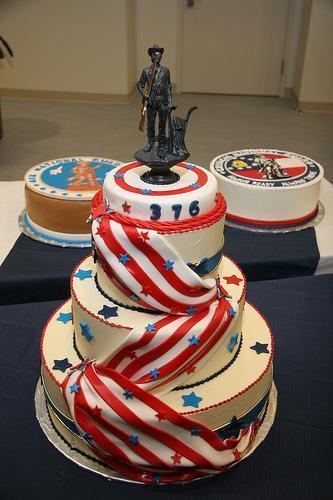How many layer is the cake?
Give a very brief answer. 3. 